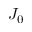Convert formula to latex. <formula><loc_0><loc_0><loc_500><loc_500>J _ { 0 }</formula> 